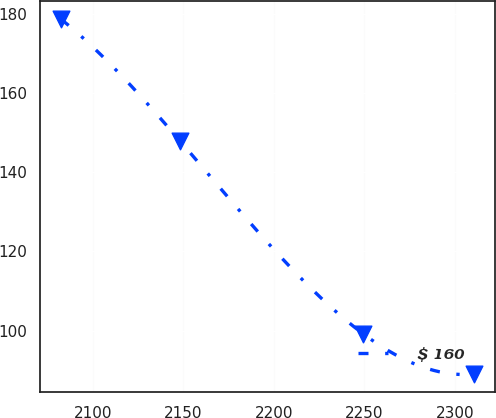Convert chart. <chart><loc_0><loc_0><loc_500><loc_500><line_chart><ecel><fcel>$ 160<nl><fcel>2082.25<fcel>178.6<nl><fcel>2148.28<fcel>147.77<nl><fcel>2249.22<fcel>99.27<nl><fcel>2310.65<fcel>89.05<nl></chart> 